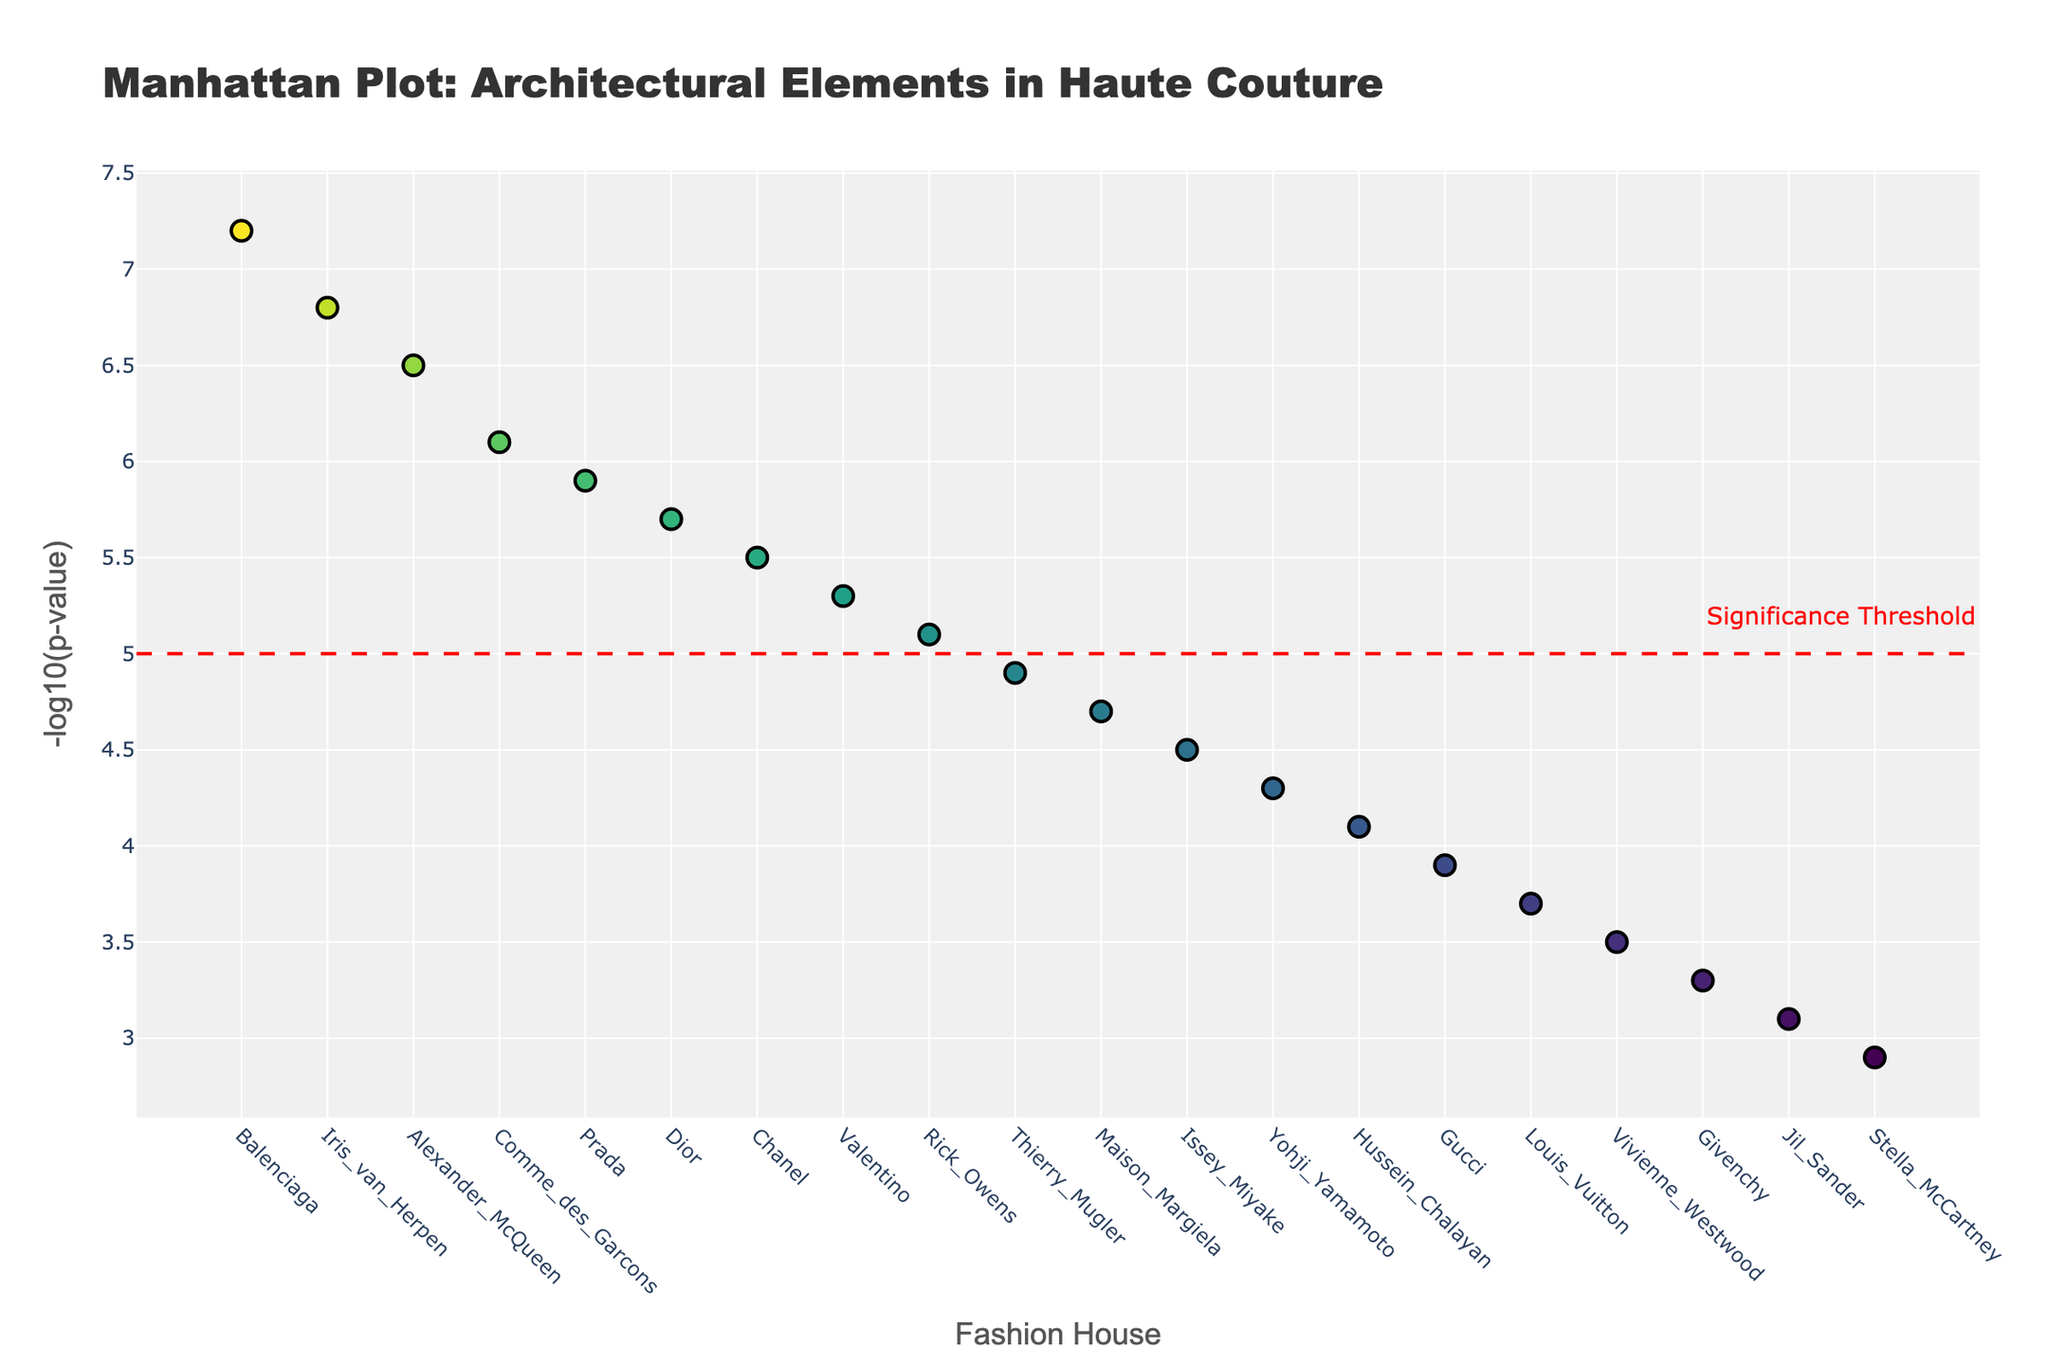What's the title of the figure? The title is displayed prominently at the top of the figure.
Answer: Manhattan Plot: Architectural Elements in Haute Couture What does the y-axis represent? The y-axis title can be seen along the vertical axis on the left side of the plot.
Answer: -log10(p-value) How many fashion houses are shown in the plot? Each fashion house is plotted along the x-axis. By counting the fashion houses, we see there are 20 in total.
Answer: 20 Which fashion house is associated with the Cantilever architectural element? By hovering over the data point with the highest y-value (7.2), the text shows "Cantilever" and "Balenciaga".
Answer: Balenciaga Which architectural element is most significantly correlated with its adoption in haute couture? The highest y-value indicates the most significant correlation, which is associated with "Cantilever" and "Balenciaga".
Answer: Cantilever What fashion house is just below the significance threshold? The red dashed line represents the significance threshold at y=5. By finding the point just below this line, we see "Vaulted Ceiling" has a y-value of 5.3 associated with "Valentino".
Answer: Valentino What is the approximate difference in Log_P_Value between 'Cantilever' and 'Spiral Staircase'? The Log_P_Value for 'Cantilever' (7.2) and 'Spiral Staircase' (4.9) is shown. The difference 7.2 - 4.9 = 2.3.
Answer: 2.3 How many architectural elements are above the significance threshold? Count the number of data points above the red dashed line at y=5. See that there are 8 points above this threshold.
Answer: 8 Which fashion house adopts the 'Geodesic Dome' architectural element and what's its significance value? Hover over the data point with Log_P_Value of 6.8, the hover text indicates "Geodesic Dome" and "Iris van Herpen".
Answer: Iris van Herpen, 6.8 What is the range of Log_P_Values represented in the plot? Subtract the smallest Log_P_Value (2.9) from the largest Log_P_Value (7.2). The range is 7.2 - 2.9 = 4.3.
Answer: 4.3 